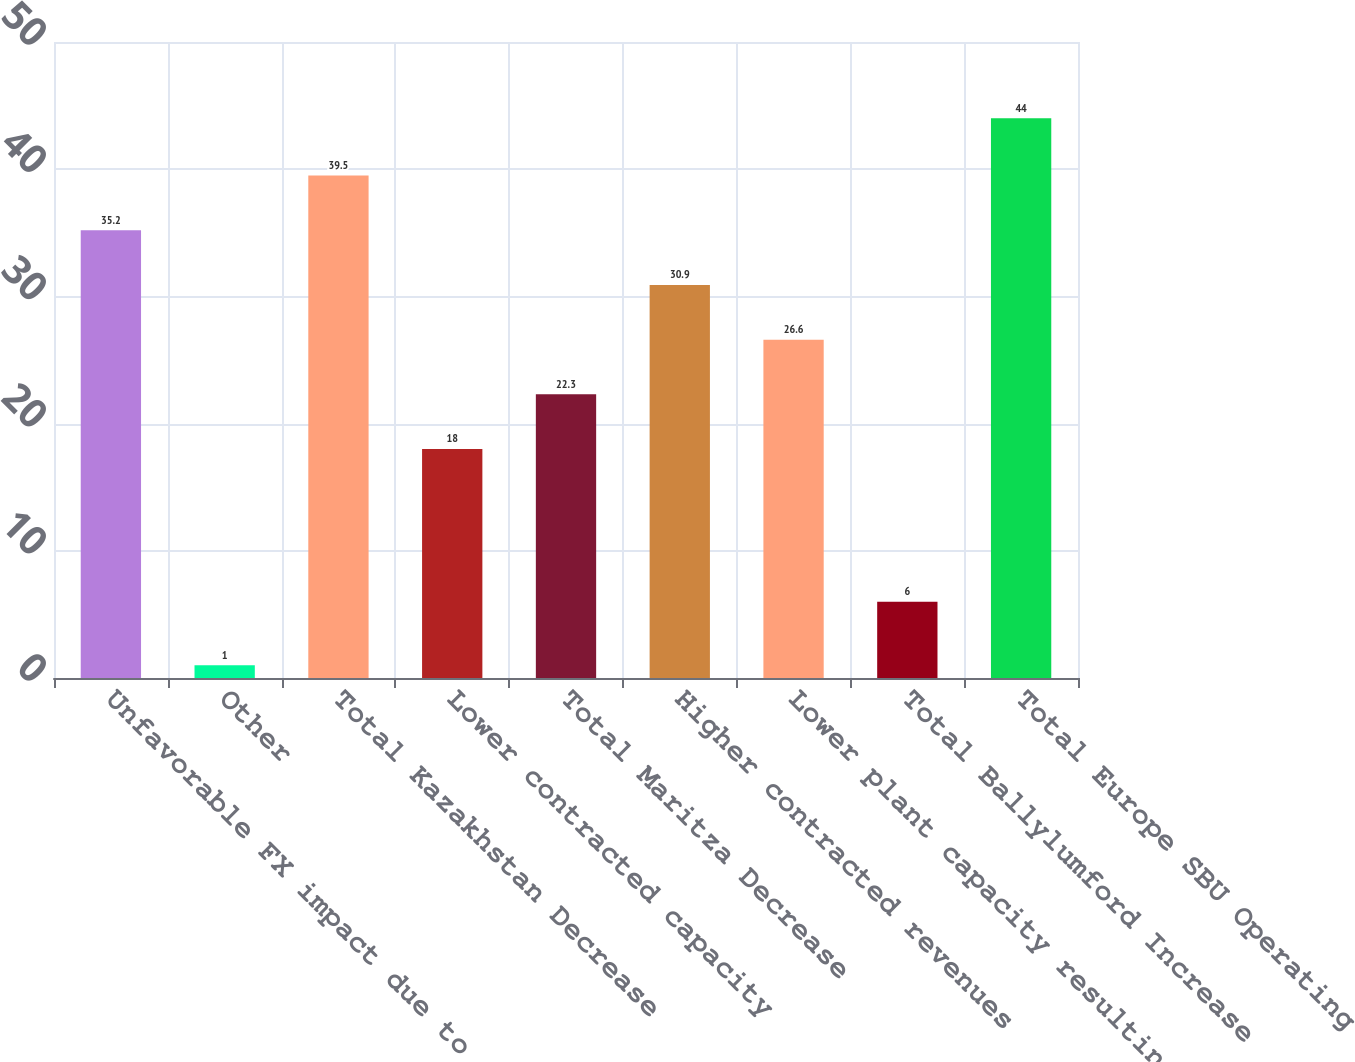Convert chart. <chart><loc_0><loc_0><loc_500><loc_500><bar_chart><fcel>Unfavorable FX impact due to<fcel>Other<fcel>Total Kazakhstan Decrease<fcel>Lower contracted capacity<fcel>Total Maritza Decrease<fcel>Higher contracted revenues<fcel>Lower plant capacity resulting<fcel>Total Ballylumford Increase<fcel>Total Europe SBU Operating<nl><fcel>35.2<fcel>1<fcel>39.5<fcel>18<fcel>22.3<fcel>30.9<fcel>26.6<fcel>6<fcel>44<nl></chart> 